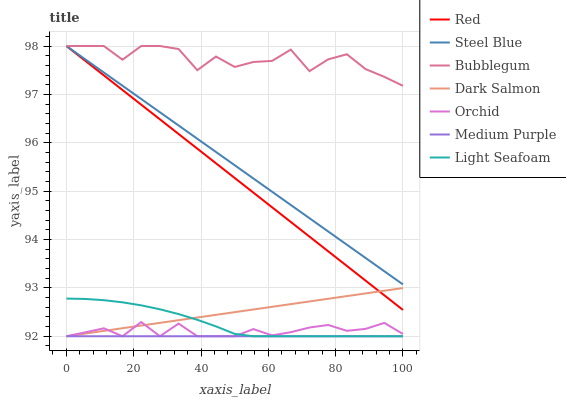Does Medium Purple have the minimum area under the curve?
Answer yes or no. Yes. Does Bubblegum have the maximum area under the curve?
Answer yes or no. Yes. Does Dark Salmon have the minimum area under the curve?
Answer yes or no. No. Does Dark Salmon have the maximum area under the curve?
Answer yes or no. No. Is Medium Purple the smoothest?
Answer yes or no. Yes. Is Bubblegum the roughest?
Answer yes or no. Yes. Is Dark Salmon the smoothest?
Answer yes or no. No. Is Dark Salmon the roughest?
Answer yes or no. No. Does Bubblegum have the lowest value?
Answer yes or no. No. Does Red have the highest value?
Answer yes or no. Yes. Does Dark Salmon have the highest value?
Answer yes or no. No. Is Orchid less than Red?
Answer yes or no. Yes. Is Bubblegum greater than Light Seafoam?
Answer yes or no. Yes. Does Orchid intersect Light Seafoam?
Answer yes or no. Yes. Is Orchid less than Light Seafoam?
Answer yes or no. No. Is Orchid greater than Light Seafoam?
Answer yes or no. No. Does Orchid intersect Red?
Answer yes or no. No. 